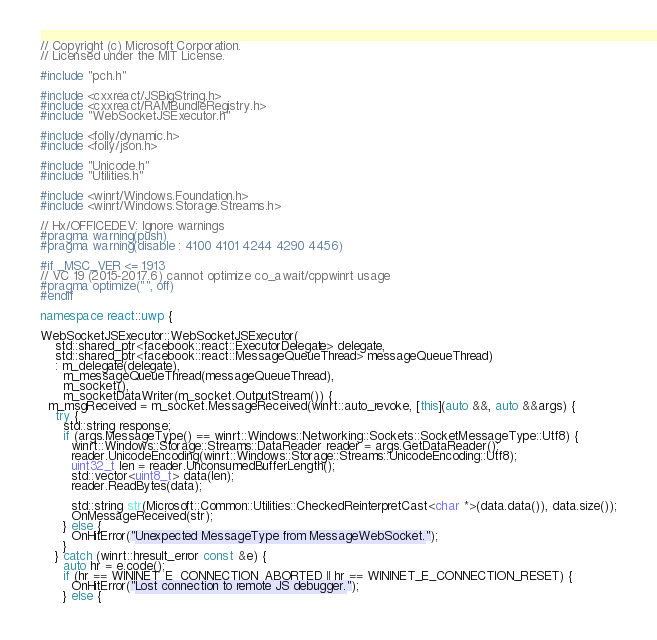Convert code to text. <code><loc_0><loc_0><loc_500><loc_500><_C++_>// Copyright (c) Microsoft Corporation.
// Licensed under the MIT License.

#include "pch.h"

#include <cxxreact/JSBigString.h>
#include <cxxreact/RAMBundleRegistry.h>
#include "WebSocketJSExecutor.h"

#include <folly/dynamic.h>
#include <folly/json.h>

#include "Unicode.h"
#include "Utilities.h"

#include <winrt/Windows.Foundation.h>
#include <winrt/Windows.Storage.Streams.h>

// Hx/OFFICEDEV: Ignore warnings
#pragma warning(push)
#pragma warning(disable : 4100 4101 4244 4290 4456)

#if _MSC_VER <= 1913
// VC 19 (2015-2017.6) cannot optimize co_await/cppwinrt usage
#pragma optimize("", off)
#endif

namespace react::uwp {

WebSocketJSExecutor::WebSocketJSExecutor(
    std::shared_ptr<facebook::react::ExecutorDelegate> delegate,
    std::shared_ptr<facebook::react::MessageQueueThread> messageQueueThread)
    : m_delegate(delegate),
      m_messageQueueThread(messageQueueThread),
      m_socket(),
      m_socketDataWriter(m_socket.OutputStream()) {
  m_msgReceived = m_socket.MessageReceived(winrt::auto_revoke, [this](auto &&, auto &&args) {
    try {
      std::string response;
      if (args.MessageType() == winrt::Windows::Networking::Sockets::SocketMessageType::Utf8) {
        winrt::Windows::Storage::Streams::DataReader reader = args.GetDataReader();
        reader.UnicodeEncoding(winrt::Windows::Storage::Streams::UnicodeEncoding::Utf8);
        uint32_t len = reader.UnconsumedBufferLength();
        std::vector<uint8_t> data(len);
        reader.ReadBytes(data);

        std::string str(Microsoft::Common::Utilities::CheckedReinterpretCast<char *>(data.data()), data.size());
        OnMessageReceived(str);
      } else {
        OnHitError("Unexpected MessageType from MessageWebSocket.");
      }
    } catch (winrt::hresult_error const &e) {
      auto hr = e.code();
      if (hr == WININET_E_CONNECTION_ABORTED || hr == WININET_E_CONNECTION_RESET) {
        OnHitError("Lost connection to remote JS debugger.");
      } else {</code> 